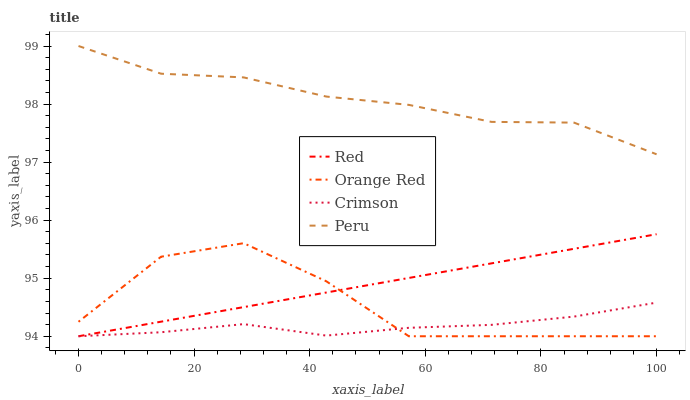Does Crimson have the minimum area under the curve?
Answer yes or no. Yes. Does Peru have the maximum area under the curve?
Answer yes or no. Yes. Does Orange Red have the minimum area under the curve?
Answer yes or no. No. Does Orange Red have the maximum area under the curve?
Answer yes or no. No. Is Red the smoothest?
Answer yes or no. Yes. Is Orange Red the roughest?
Answer yes or no. Yes. Is Peru the smoothest?
Answer yes or no. No. Is Peru the roughest?
Answer yes or no. No. Does Crimson have the lowest value?
Answer yes or no. Yes. Does Peru have the lowest value?
Answer yes or no. No. Does Peru have the highest value?
Answer yes or no. Yes. Does Orange Red have the highest value?
Answer yes or no. No. Is Red less than Peru?
Answer yes or no. Yes. Is Peru greater than Red?
Answer yes or no. Yes. Does Orange Red intersect Crimson?
Answer yes or no. Yes. Is Orange Red less than Crimson?
Answer yes or no. No. Is Orange Red greater than Crimson?
Answer yes or no. No. Does Red intersect Peru?
Answer yes or no. No. 